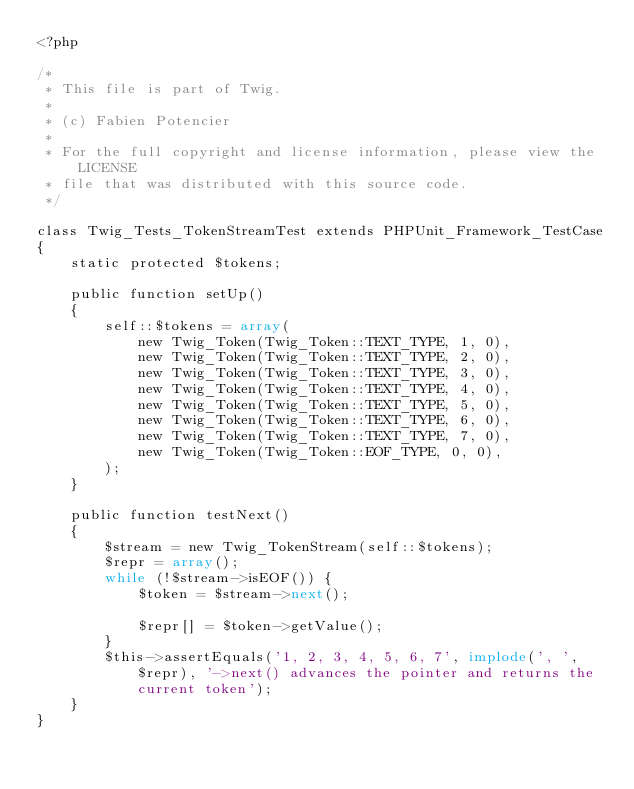<code> <loc_0><loc_0><loc_500><loc_500><_PHP_><?php

/*
 * This file is part of Twig.
 *
 * (c) Fabien Potencier
 *
 * For the full copyright and license information, please view the LICENSE
 * file that was distributed with this source code.
 */

class Twig_Tests_TokenStreamTest extends PHPUnit_Framework_TestCase
{
    static protected $tokens;

    public function setUp()
    {
        self::$tokens = array(
            new Twig_Token(Twig_Token::TEXT_TYPE, 1, 0),
            new Twig_Token(Twig_Token::TEXT_TYPE, 2, 0),
            new Twig_Token(Twig_Token::TEXT_TYPE, 3, 0),
            new Twig_Token(Twig_Token::TEXT_TYPE, 4, 0),
            new Twig_Token(Twig_Token::TEXT_TYPE, 5, 0),
            new Twig_Token(Twig_Token::TEXT_TYPE, 6, 0),
            new Twig_Token(Twig_Token::TEXT_TYPE, 7, 0),
            new Twig_Token(Twig_Token::EOF_TYPE, 0, 0),
        );
    }

    public function testNext()
    {
        $stream = new Twig_TokenStream(self::$tokens);
        $repr = array();
        while (!$stream->isEOF()) {
            $token = $stream->next();

            $repr[] = $token->getValue();
        }
        $this->assertEquals('1, 2, 3, 4, 5, 6, 7', implode(', ', $repr), '->next() advances the pointer and returns the current token');
    }
}
</code> 